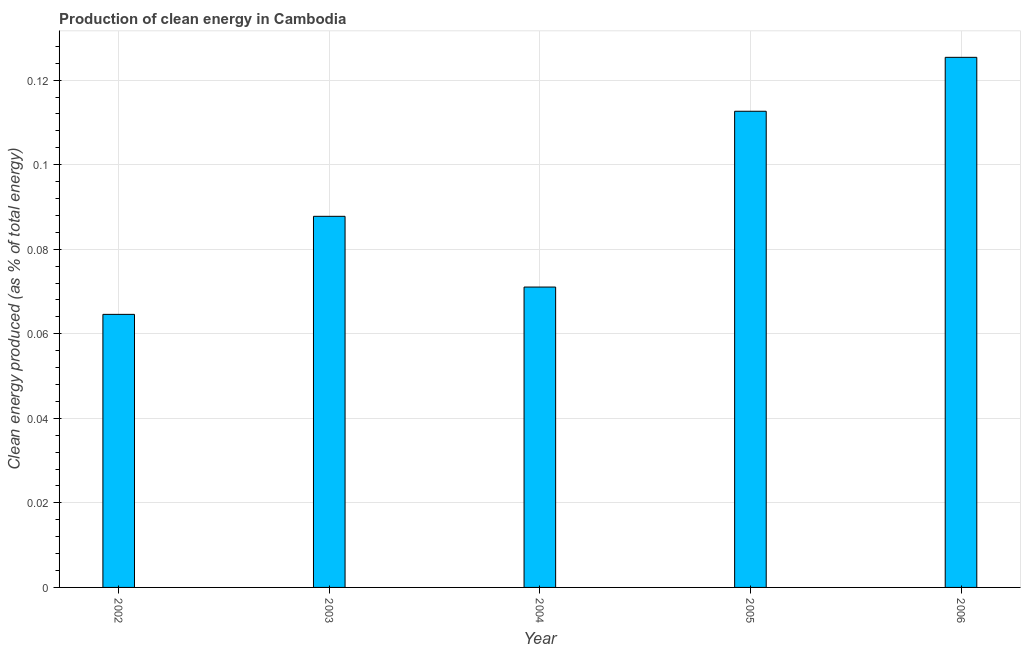Does the graph contain grids?
Keep it short and to the point. Yes. What is the title of the graph?
Provide a short and direct response. Production of clean energy in Cambodia. What is the label or title of the X-axis?
Make the answer very short. Year. What is the label or title of the Y-axis?
Your response must be concise. Clean energy produced (as % of total energy). What is the production of clean energy in 2002?
Ensure brevity in your answer.  0.06. Across all years, what is the maximum production of clean energy?
Provide a succinct answer. 0.13. Across all years, what is the minimum production of clean energy?
Give a very brief answer. 0.06. In which year was the production of clean energy maximum?
Provide a short and direct response. 2006. In which year was the production of clean energy minimum?
Ensure brevity in your answer.  2002. What is the sum of the production of clean energy?
Provide a succinct answer. 0.46. What is the difference between the production of clean energy in 2003 and 2004?
Your answer should be very brief. 0.02. What is the average production of clean energy per year?
Your answer should be very brief. 0.09. What is the median production of clean energy?
Make the answer very short. 0.09. What is the ratio of the production of clean energy in 2004 to that in 2005?
Provide a succinct answer. 0.63. Is the difference between the production of clean energy in 2002 and 2003 greater than the difference between any two years?
Your response must be concise. No. What is the difference between the highest and the second highest production of clean energy?
Provide a short and direct response. 0.01. What is the difference between the highest and the lowest production of clean energy?
Make the answer very short. 0.06. In how many years, is the production of clean energy greater than the average production of clean energy taken over all years?
Make the answer very short. 2. How many bars are there?
Ensure brevity in your answer.  5. How many years are there in the graph?
Your response must be concise. 5. What is the difference between two consecutive major ticks on the Y-axis?
Ensure brevity in your answer.  0.02. Are the values on the major ticks of Y-axis written in scientific E-notation?
Provide a succinct answer. No. What is the Clean energy produced (as % of total energy) in 2002?
Your answer should be compact. 0.06. What is the Clean energy produced (as % of total energy) of 2003?
Your response must be concise. 0.09. What is the Clean energy produced (as % of total energy) in 2004?
Give a very brief answer. 0.07. What is the Clean energy produced (as % of total energy) of 2005?
Keep it short and to the point. 0.11. What is the Clean energy produced (as % of total energy) of 2006?
Your response must be concise. 0.13. What is the difference between the Clean energy produced (as % of total energy) in 2002 and 2003?
Provide a short and direct response. -0.02. What is the difference between the Clean energy produced (as % of total energy) in 2002 and 2004?
Make the answer very short. -0.01. What is the difference between the Clean energy produced (as % of total energy) in 2002 and 2005?
Provide a succinct answer. -0.05. What is the difference between the Clean energy produced (as % of total energy) in 2002 and 2006?
Provide a succinct answer. -0.06. What is the difference between the Clean energy produced (as % of total energy) in 2003 and 2004?
Provide a short and direct response. 0.02. What is the difference between the Clean energy produced (as % of total energy) in 2003 and 2005?
Your answer should be compact. -0.02. What is the difference between the Clean energy produced (as % of total energy) in 2003 and 2006?
Your answer should be very brief. -0.04. What is the difference between the Clean energy produced (as % of total energy) in 2004 and 2005?
Give a very brief answer. -0.04. What is the difference between the Clean energy produced (as % of total energy) in 2004 and 2006?
Keep it short and to the point. -0.05. What is the difference between the Clean energy produced (as % of total energy) in 2005 and 2006?
Provide a short and direct response. -0.01. What is the ratio of the Clean energy produced (as % of total energy) in 2002 to that in 2003?
Provide a succinct answer. 0.74. What is the ratio of the Clean energy produced (as % of total energy) in 2002 to that in 2004?
Ensure brevity in your answer.  0.91. What is the ratio of the Clean energy produced (as % of total energy) in 2002 to that in 2005?
Your answer should be compact. 0.57. What is the ratio of the Clean energy produced (as % of total energy) in 2002 to that in 2006?
Provide a succinct answer. 0.52. What is the ratio of the Clean energy produced (as % of total energy) in 2003 to that in 2004?
Provide a short and direct response. 1.24. What is the ratio of the Clean energy produced (as % of total energy) in 2003 to that in 2005?
Ensure brevity in your answer.  0.78. What is the ratio of the Clean energy produced (as % of total energy) in 2003 to that in 2006?
Offer a terse response. 0.7. What is the ratio of the Clean energy produced (as % of total energy) in 2004 to that in 2005?
Make the answer very short. 0.63. What is the ratio of the Clean energy produced (as % of total energy) in 2004 to that in 2006?
Provide a short and direct response. 0.57. What is the ratio of the Clean energy produced (as % of total energy) in 2005 to that in 2006?
Keep it short and to the point. 0.9. 